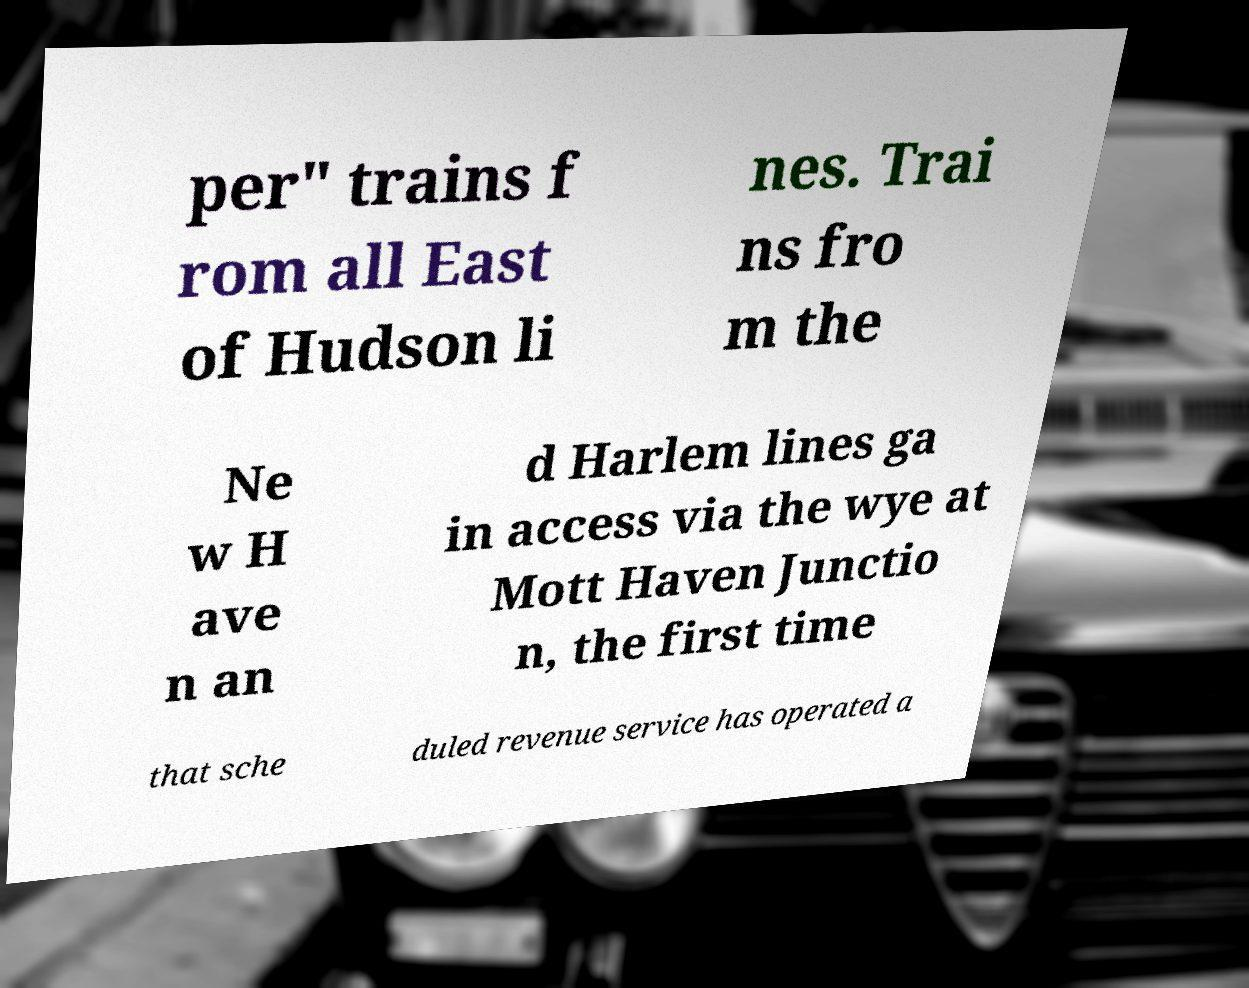What messages or text are displayed in this image? I need them in a readable, typed format. per" trains f rom all East of Hudson li nes. Trai ns fro m the Ne w H ave n an d Harlem lines ga in access via the wye at Mott Haven Junctio n, the first time that sche duled revenue service has operated a 